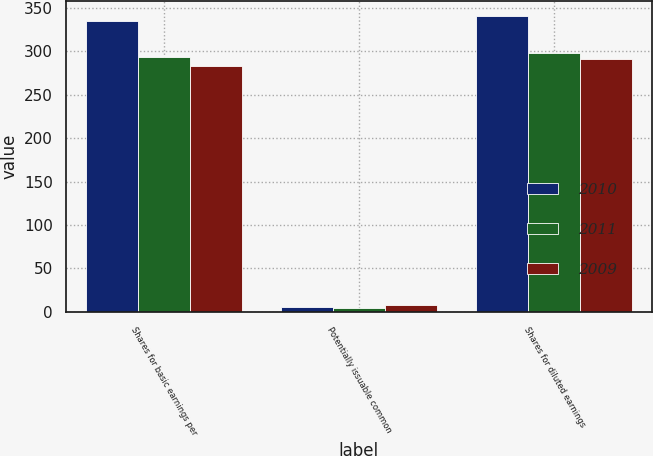Convert chart. <chart><loc_0><loc_0><loc_500><loc_500><stacked_bar_chart><ecel><fcel>Shares for basic earnings per<fcel>Potentially issuable common<fcel>Shares for diluted earnings<nl><fcel>2010<fcel>335.5<fcel>5.4<fcel>340.9<nl><fcel>2011<fcel>293.4<fcel>4.7<fcel>298.1<nl><fcel>2009<fcel>283.2<fcel>7.9<fcel>291.1<nl></chart> 